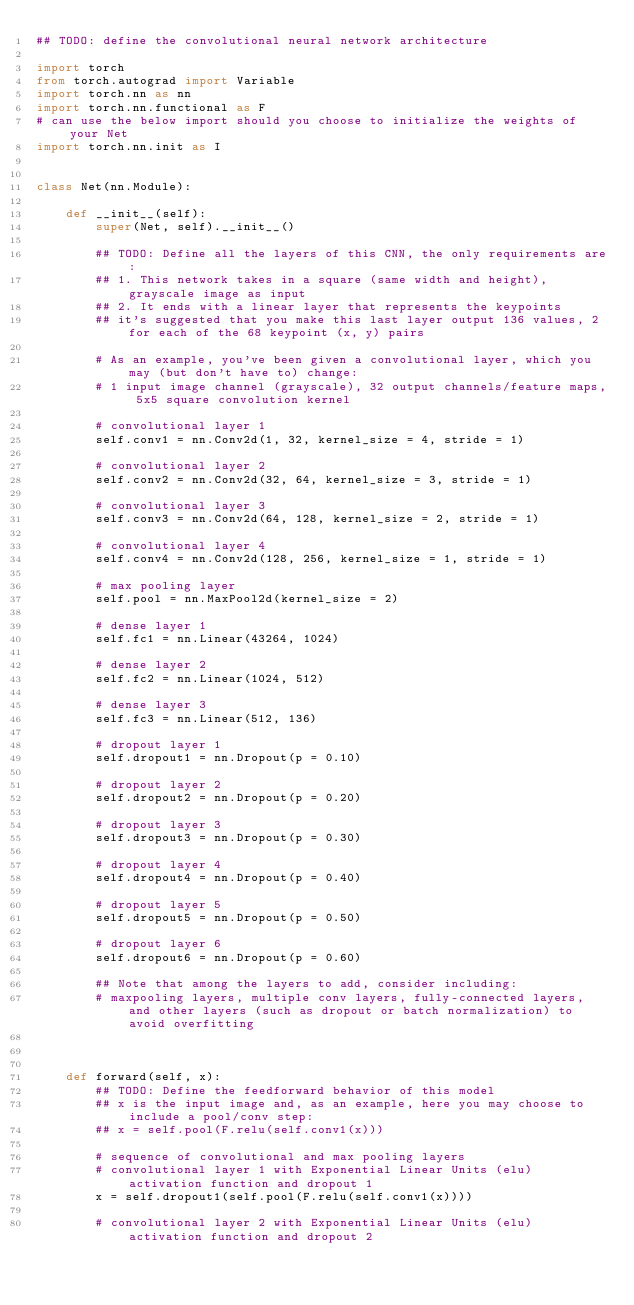Convert code to text. <code><loc_0><loc_0><loc_500><loc_500><_Python_>## TODO: define the convolutional neural network architecture

import torch
from torch.autograd import Variable
import torch.nn as nn
import torch.nn.functional as F
# can use the below import should you choose to initialize the weights of your Net
import torch.nn.init as I


class Net(nn.Module):

    def __init__(self):
        super(Net, self).__init__()
        
        ## TODO: Define all the layers of this CNN, the only requirements are:
        ## 1. This network takes in a square (same width and height), grayscale image as input
        ## 2. It ends with a linear layer that represents the keypoints
        ## it's suggested that you make this last layer output 136 values, 2 for each of the 68 keypoint (x, y) pairs
        
        # As an example, you've been given a convolutional layer, which you may (but don't have to) change:
        # 1 input image channel (grayscale), 32 output channels/feature maps, 5x5 square convolution kernel
        
        # convolutional layer 1
        self.conv1 = nn.Conv2d(1, 32, kernel_size = 4, stride = 1)
        
        # convolutional layer 2
        self.conv2 = nn.Conv2d(32, 64, kernel_size = 3, stride = 1)
        
        # convolutional layer 3
        self.conv3 = nn.Conv2d(64, 128, kernel_size = 2, stride = 1)
        
        # convolutional layer 4
        self.conv4 = nn.Conv2d(128, 256, kernel_size = 1, stride = 1)
        
        # max pooling layer
        self.pool = nn.MaxPool2d(kernel_size = 2)
        
        # dense layer 1
        self.fc1 = nn.Linear(43264, 1024)
        
        # dense layer 2
        self.fc2 = nn.Linear(1024, 512)
        
        # dense layer 3
        self.fc3 = nn.Linear(512, 136)
        
        # dropout layer 1
        self.dropout1 = nn.Dropout(p = 0.10)

        # dropout layer 2
        self.dropout2 = nn.Dropout(p = 0.20)

        # dropout layer 3
        self.dropout3 = nn.Dropout(p = 0.30)

        # dropout layer 4
        self.dropout4 = nn.Dropout(p = 0.40)

        # dropout layer 5
        self.dropout5 = nn.Dropout(p = 0.50)

        # dropout layer 6
        self.dropout6 = nn.Dropout(p = 0.60)
        
        ## Note that among the layers to add, consider including:
        # maxpooling layers, multiple conv layers, fully-connected layers, and other layers (such as dropout or batch normalization) to avoid overfitting
        

        
    def forward(self, x):
        ## TODO: Define the feedforward behavior of this model
        ## x is the input image and, as an example, here you may choose to include a pool/conv step:
        ## x = self.pool(F.relu(self.conv1(x)))
        
        # sequence of convolutional and max pooling layers
        # convolutional layer 1 with Exponential Linear Units (elu) activation function and dropout 1
        x = self.dropout1(self.pool(F.relu(self.conv1(x))))
        
        # convolutional layer 2 with Exponential Linear Units (elu) activation function and dropout 2</code> 